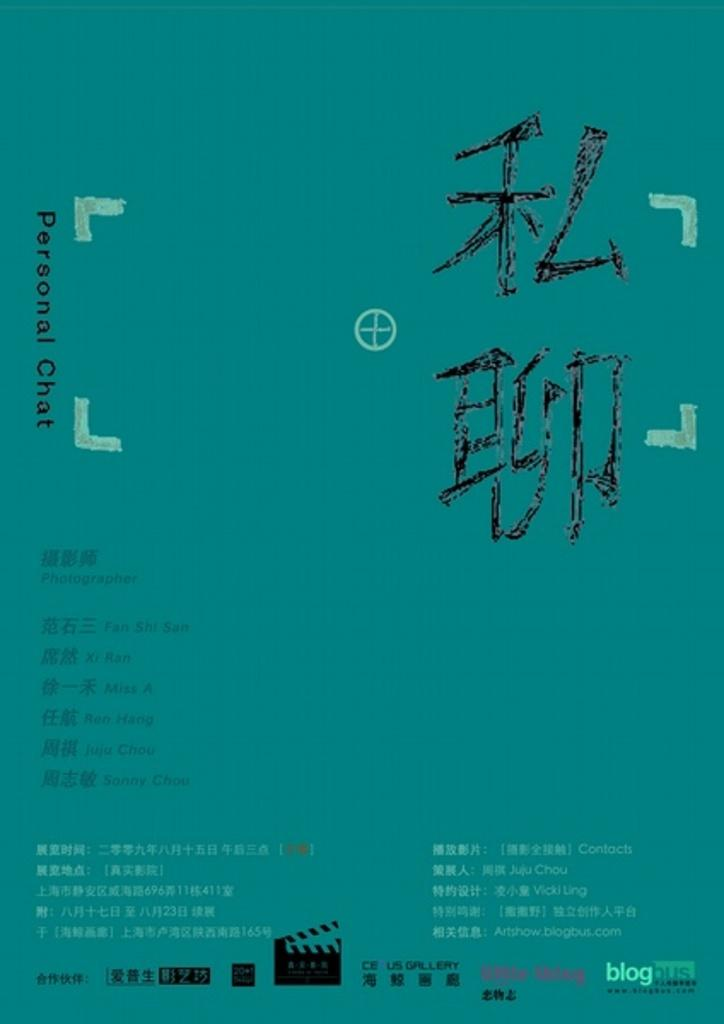<image>
Summarize the visual content of the image. A flyer labeled personal chat is filled with several areas of Asian language text. 